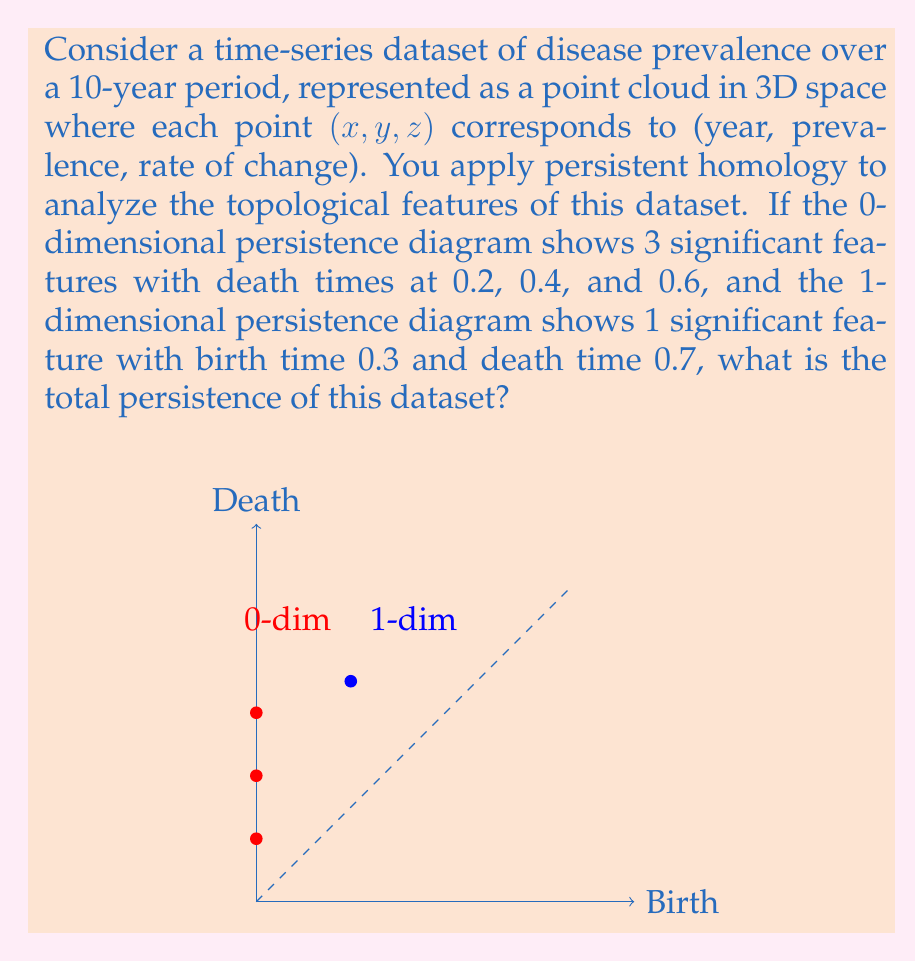Provide a solution to this math problem. To solve this problem, we need to understand persistent homology and how to calculate total persistence:

1) Persistent homology quantifies topological features (e.g., connected components, loops) that persist across multiple scales.

2) The persistence diagram visualizes these features, with the x-axis representing birth time and the y-axis representing death time.

3) Total persistence is the sum of all persistence values, where persistence is defined as (death time - birth time) for each feature.

4) For 0-dimensional features (connected components), the birth time is always 0.

Let's calculate the persistence for each feature:

0-dimensional features:
- Feature 1: $0.2 - 0 = 0.2$
- Feature 2: $0.4 - 0 = 0.4$
- Feature 3: $0.6 - 0 = 0.6$

1-dimensional feature:
- Feature 1: $0.7 - 0.3 = 0.4$

Now, we sum all these persistence values:

$$\text{Total Persistence} = 0.2 + 0.4 + 0.6 + 0.4 = 1.6$$

Therefore, the total persistence of this dataset is 1.6.
Answer: 1.6 